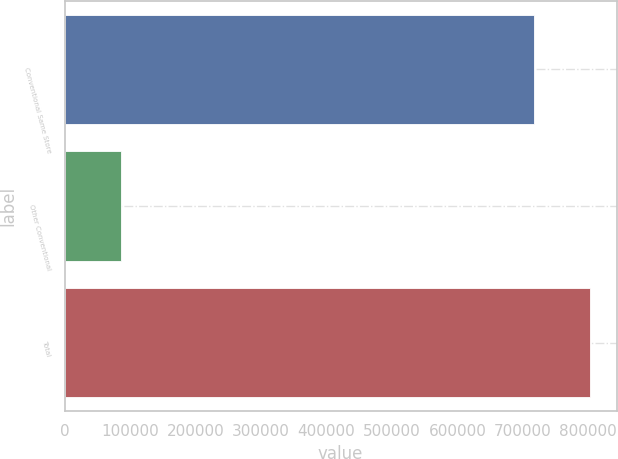<chart> <loc_0><loc_0><loc_500><loc_500><bar_chart><fcel>Conventional Same Store<fcel>Other Conventional<fcel>Total<nl><fcel>716618<fcel>86624<fcel>803242<nl></chart> 